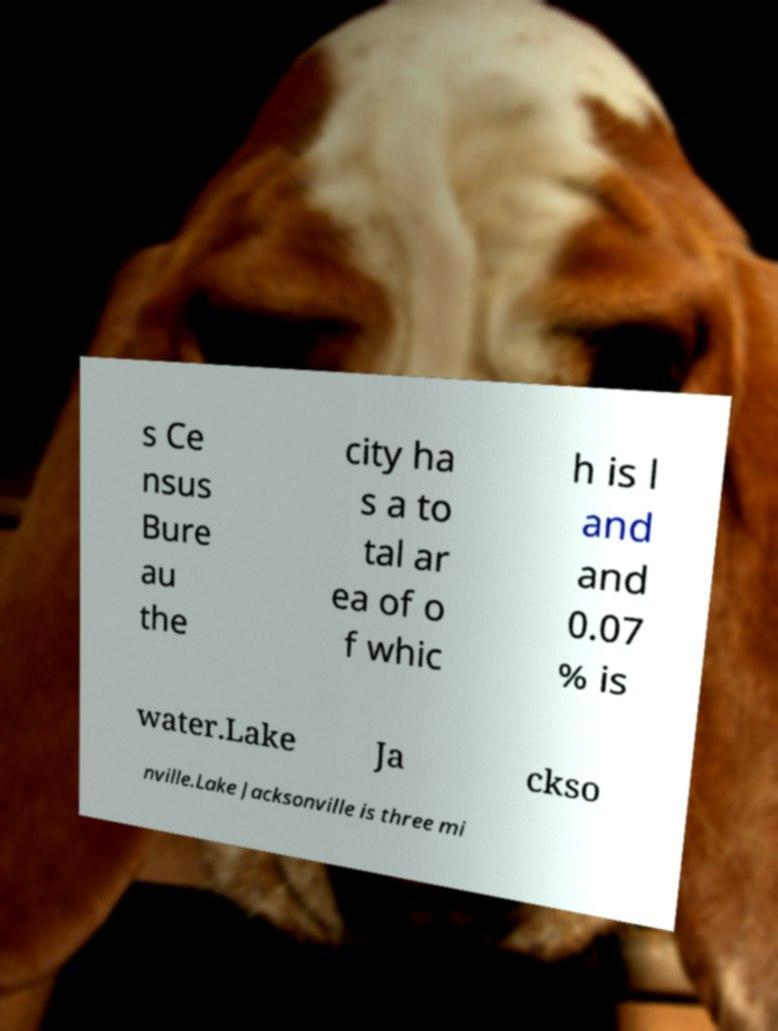I need the written content from this picture converted into text. Can you do that? s Ce nsus Bure au the city ha s a to tal ar ea of o f whic h is l and and 0.07 % is water.Lake Ja ckso nville.Lake Jacksonville is three mi 